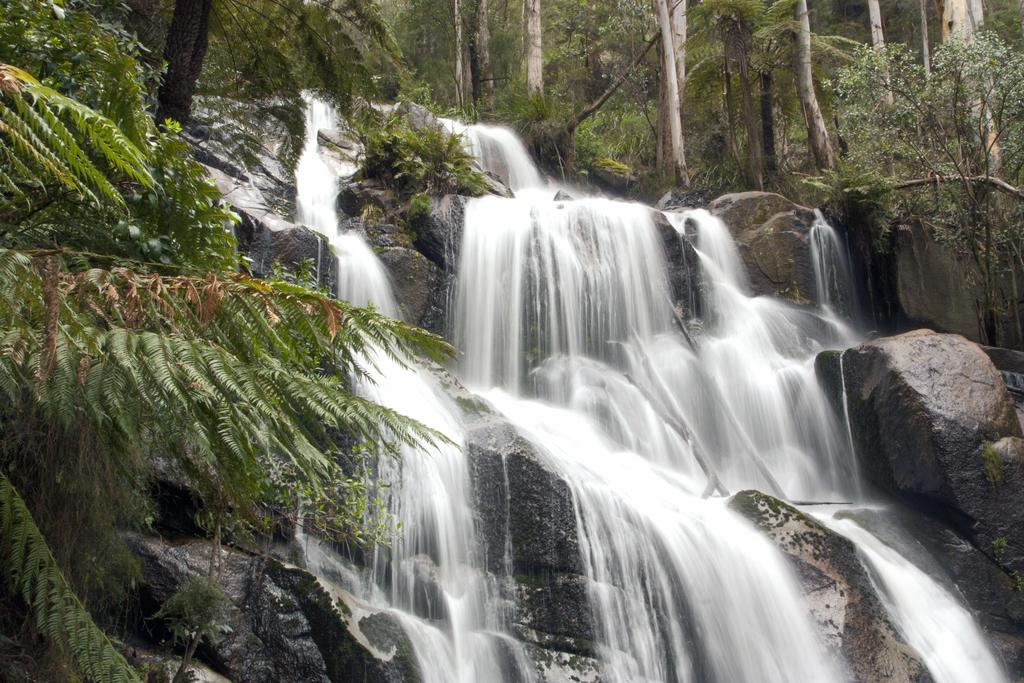What natural feature is the main subject of the image? There is a waterfall in the image. What type of vegetation can be seen in the image? There are trees and plants in the image. What theory is being discussed by the crowd of cats in the image? There is no crowd of cats present in the image, and therefore no discussion or theory can be observed. 